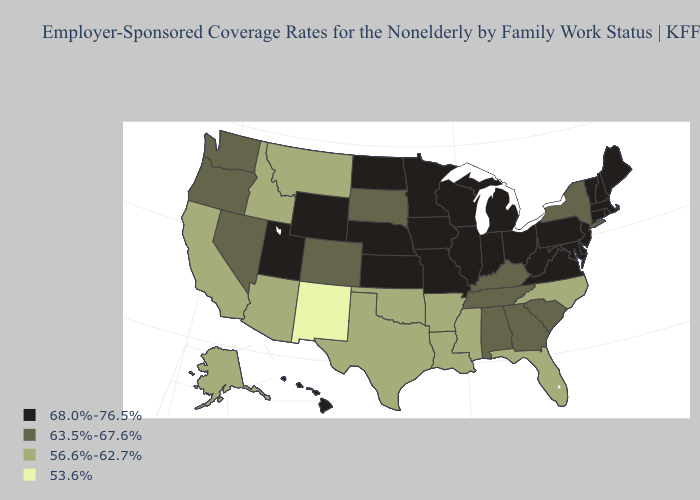What is the value of Kansas?
Be succinct. 68.0%-76.5%. Name the states that have a value in the range 63.5%-67.6%?
Write a very short answer. Alabama, Colorado, Georgia, Kentucky, Nevada, New York, Oregon, South Carolina, South Dakota, Tennessee, Washington. What is the lowest value in states that border Oregon?
Quick response, please. 56.6%-62.7%. Does Ohio have a higher value than Florida?
Concise answer only. Yes. Among the states that border Arkansas , which have the highest value?
Quick response, please. Missouri. What is the highest value in the USA?
Short answer required. 68.0%-76.5%. Among the states that border Nevada , which have the lowest value?
Be succinct. Arizona, California, Idaho. What is the value of Illinois?
Be succinct. 68.0%-76.5%. What is the highest value in the USA?
Answer briefly. 68.0%-76.5%. Name the states that have a value in the range 56.6%-62.7%?
Write a very short answer. Alaska, Arizona, Arkansas, California, Florida, Idaho, Louisiana, Mississippi, Montana, North Carolina, Oklahoma, Texas. Name the states that have a value in the range 68.0%-76.5%?
Keep it brief. Connecticut, Delaware, Hawaii, Illinois, Indiana, Iowa, Kansas, Maine, Maryland, Massachusetts, Michigan, Minnesota, Missouri, Nebraska, New Hampshire, New Jersey, North Dakota, Ohio, Pennsylvania, Rhode Island, Utah, Vermont, Virginia, West Virginia, Wisconsin, Wyoming. Name the states that have a value in the range 68.0%-76.5%?
Concise answer only. Connecticut, Delaware, Hawaii, Illinois, Indiana, Iowa, Kansas, Maine, Maryland, Massachusetts, Michigan, Minnesota, Missouri, Nebraska, New Hampshire, New Jersey, North Dakota, Ohio, Pennsylvania, Rhode Island, Utah, Vermont, Virginia, West Virginia, Wisconsin, Wyoming. Does Arizona have a lower value than Arkansas?
Short answer required. No. Name the states that have a value in the range 56.6%-62.7%?
Keep it brief. Alaska, Arizona, Arkansas, California, Florida, Idaho, Louisiana, Mississippi, Montana, North Carolina, Oklahoma, Texas. 